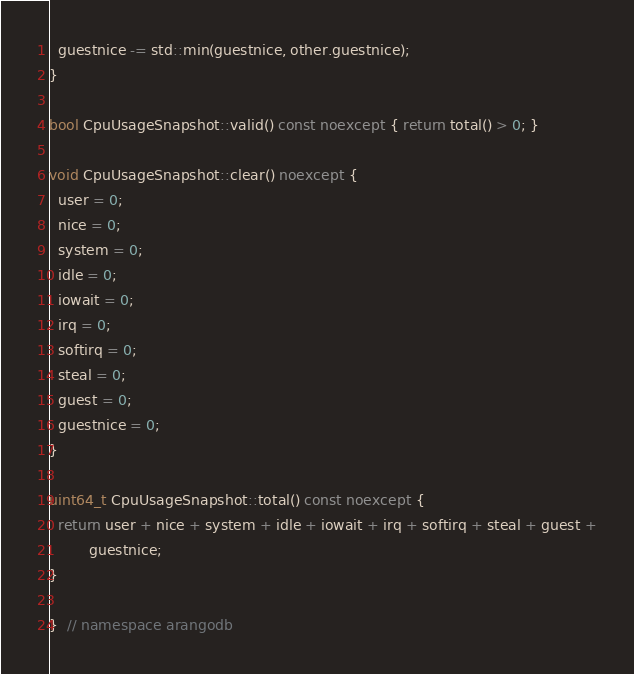Convert code to text. <code><loc_0><loc_0><loc_500><loc_500><_C++_>  guestnice -= std::min(guestnice, other.guestnice);
}

bool CpuUsageSnapshot::valid() const noexcept { return total() > 0; }

void CpuUsageSnapshot::clear() noexcept {
  user = 0;
  nice = 0;
  system = 0;
  idle = 0;
  iowait = 0;
  irq = 0;
  softirq = 0;
  steal = 0;
  guest = 0;
  guestnice = 0;
}

uint64_t CpuUsageSnapshot::total() const noexcept {
  return user + nice + system + idle + iowait + irq + softirq + steal + guest +
         guestnice;
}

}  // namespace arangodb
</code> 